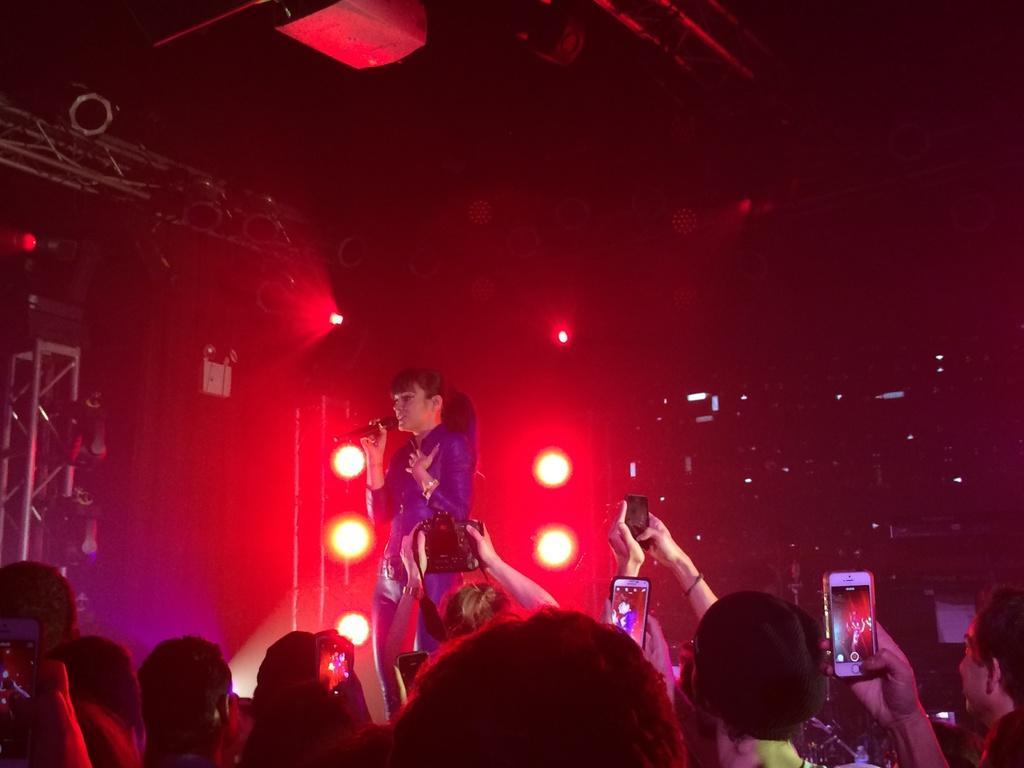Can you describe this image briefly? In this picture there are people, among them few people holding mobiles. There is a woman standing and holding a microphone. In the background of the image it is dark and we can see rods and focusing lights. 